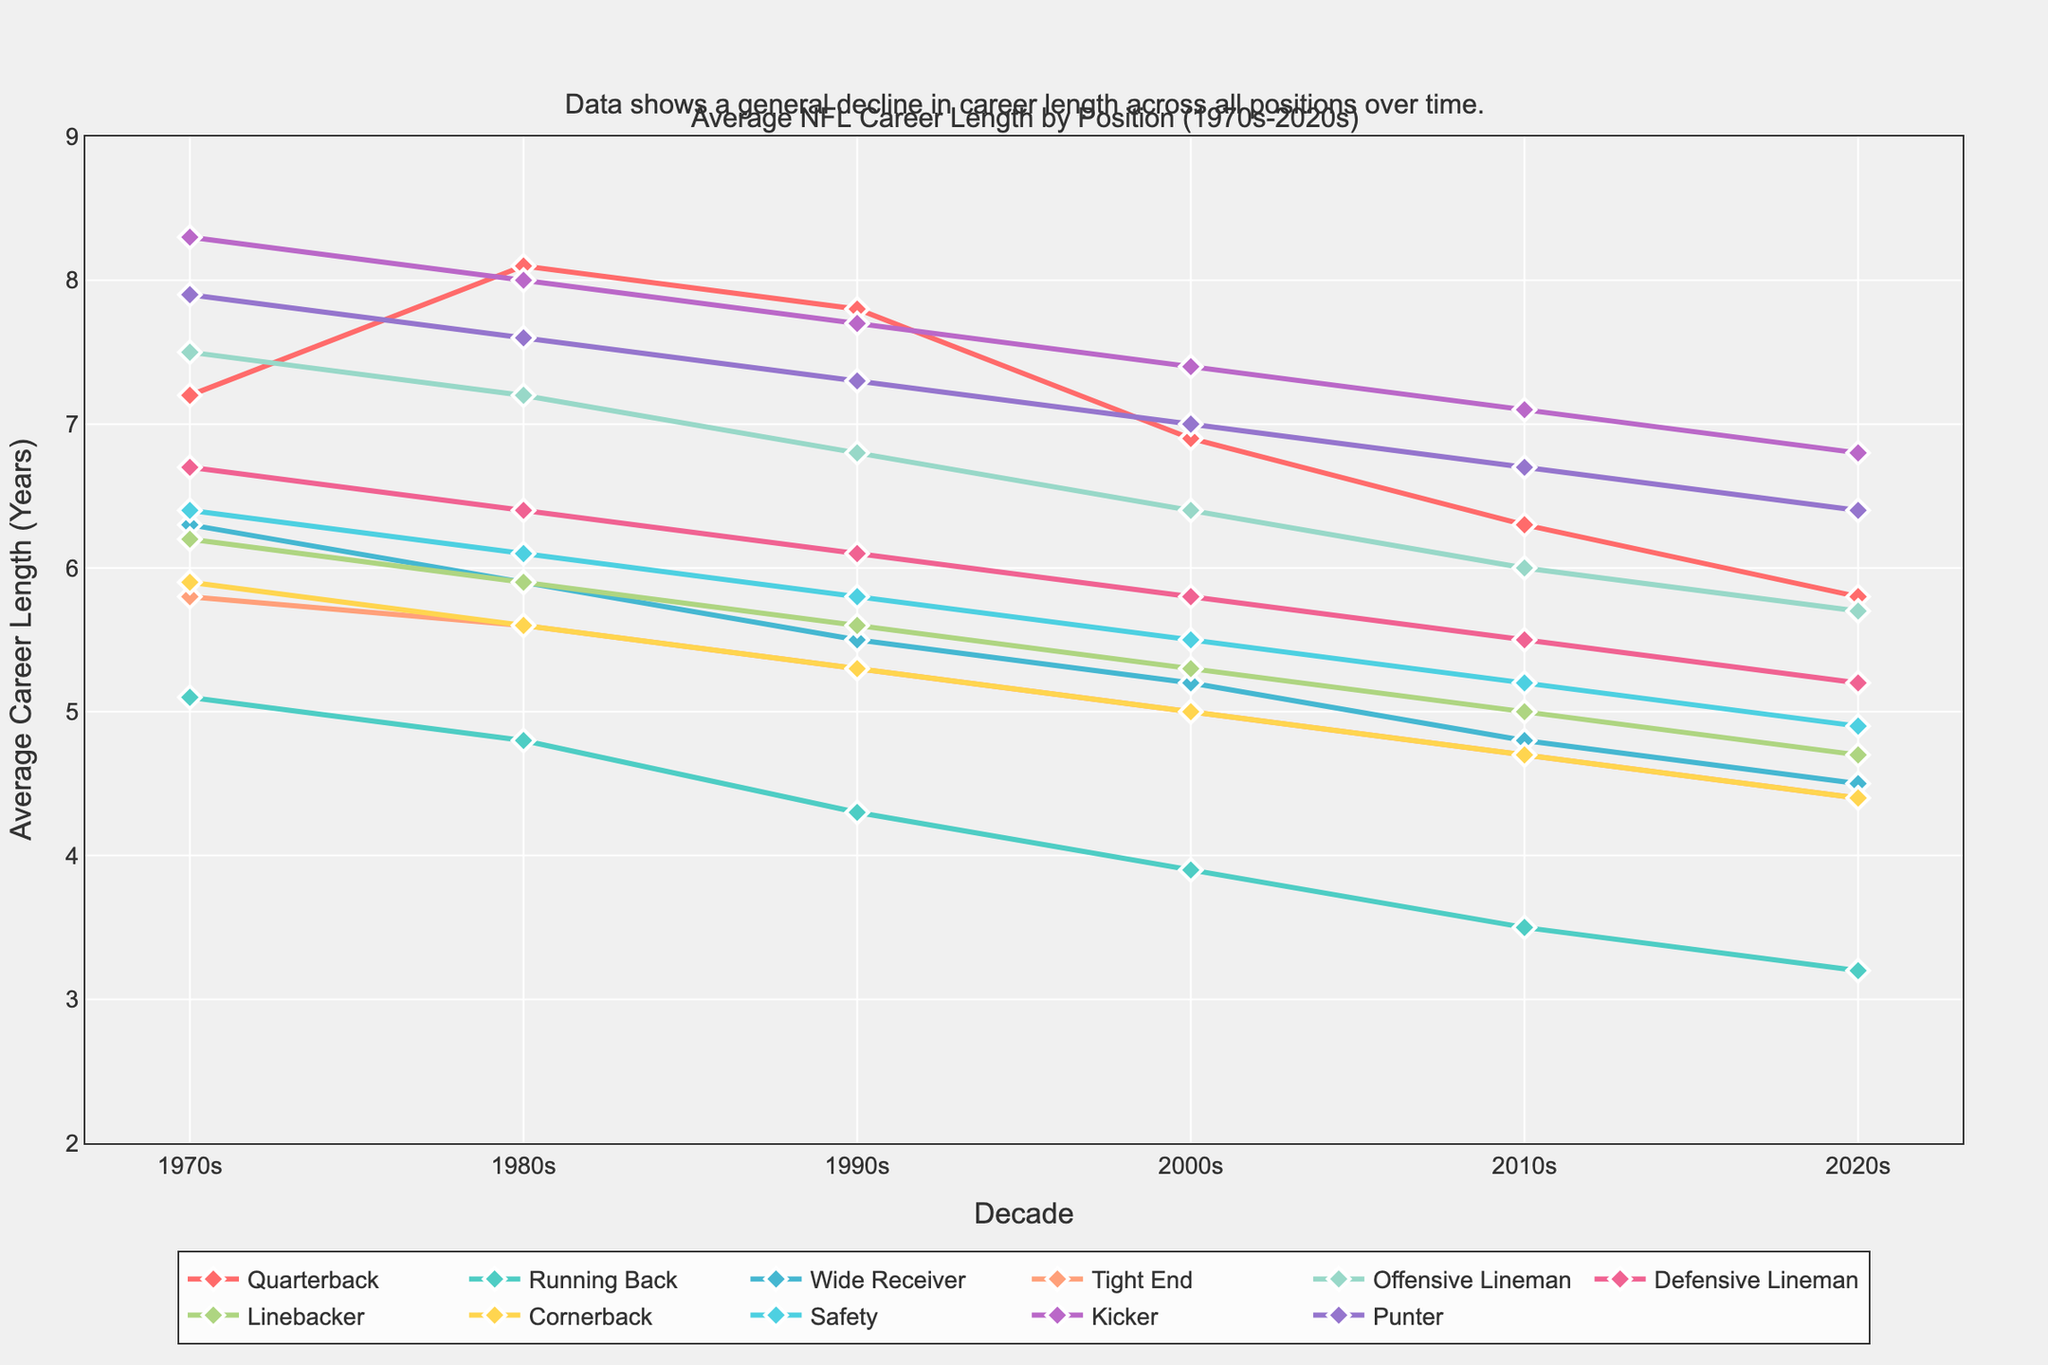What position had the longest average career length in the 1970s? To find the answer, look at the vertical height of the lines for the 1970s decade. The position with the highest value is for Kickers.
Answer: Kickers How did the average career length of quarterbacks change from the 1970s to the 2020s? Compare the height of the line for quarterbacks from the 1970s to the 2020s. It starts at 7.2 years and decreases to 5.8 years.
Answer: Decreased Which position had the shortest average career length in the 2020s? Look at the endpoint of each line in the 2020s. The position with the lowest value is Running Backs.
Answer: Running Backs Which two positions showed the greatest decline in average career length from the 1970s to the 2020s? Subtract the 2020s values from the 1970s values for each position. Running Backs (5.1 - 3.2 = 1.9) and Offensive Linemen (7.5 - 5.7 = 1.8) show the greatest decline.
Answer: Running Backs & Offensive Linemen What was the average career length for Tight Ends in the 2000s, and how does it compare to the 2010s? Look at the values for Tight Ends in the 2000s (5.0) and the 2010s (4.7). Compare these values to see the difference.
Answer: 5.0 years in 2000s, decreased by 0.3 years in 2010s Which position had a longer average career length in the 1980s, Wide Receiver or Safety? Compare the vertical height of the lines for Wide Receivers and Safeties in the 1980s. Wide Receivers are lower at 5.9 compared to Safeties at 6.1.
Answer: Safety What position consistently had the longest average career length across all decades? Examine the heights of the lines from the 1970s to the 2020s for all positions and see which one remains the highest throughout. Kickers have the highest values consistently.
Answer: Kickers By how much did the average career length of Linebackers change from the 1970s to the 2020s? Calculate the difference between the values for Linebackers in the 1970s (6.2) and the 2020s (4.7). The difference is 1.5 years.
Answer: 1.5 years Which position shows the least variability in its career length over the decades? To find this, visually compare the lines for all positions and find the one with the least amount of change (i.e., the flattest line). Punters showed the least variability.
Answer: Punters 